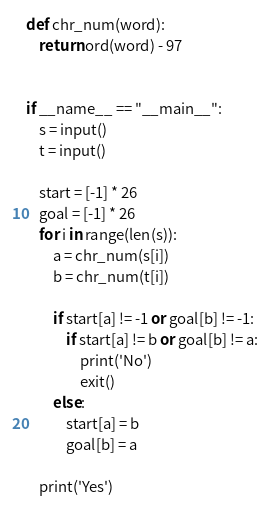Convert code to text. <code><loc_0><loc_0><loc_500><loc_500><_Python_>def chr_num(word):
    return ord(word) - 97


if __name__ == "__main__":
    s = input()
    t = input()

    start = [-1] * 26
    goal = [-1] * 26
    for i in range(len(s)):
        a = chr_num(s[i])
        b = chr_num(t[i])

        if start[a] != -1 or goal[b] != -1:
            if start[a] != b or goal[b] != a:
                print('No')
                exit()
        else:
            start[a] = b
            goal[b] = a

    print('Yes')
</code> 